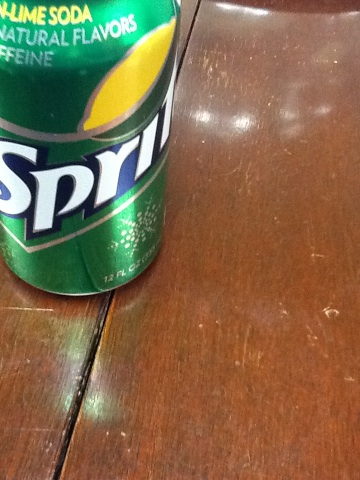What does this say? The image displays a can of Sprite, identifiable by the logo. The label prominently features the words 'SPRITE', along with the description 'LIME SODA' and 'NATURAL FLAVORS' above the logo. It also mentions that the soda contains 'CAFFEINE'. 